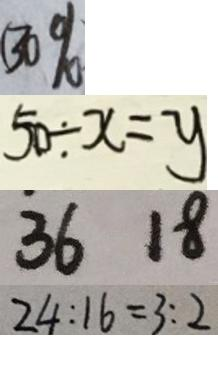<formula> <loc_0><loc_0><loc_500><loc_500>( 3 0 \% 
 5 0 \div x = y 
 3 6 1 8 
 2 4 : 1 6 = 3 : 2</formula> 